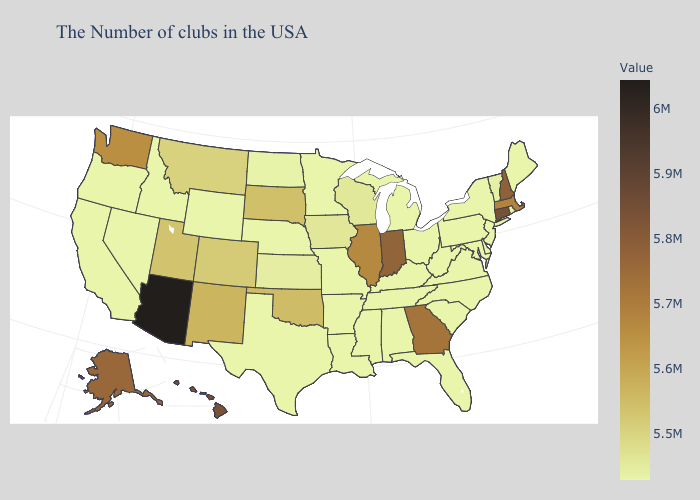Does Iowa have the lowest value in the USA?
Keep it brief. No. Does Florida have the highest value in the South?
Be succinct. No. Among the states that border Wisconsin , does Minnesota have the highest value?
Give a very brief answer. No. Does Virginia have a lower value than South Dakota?
Short answer required. Yes. 